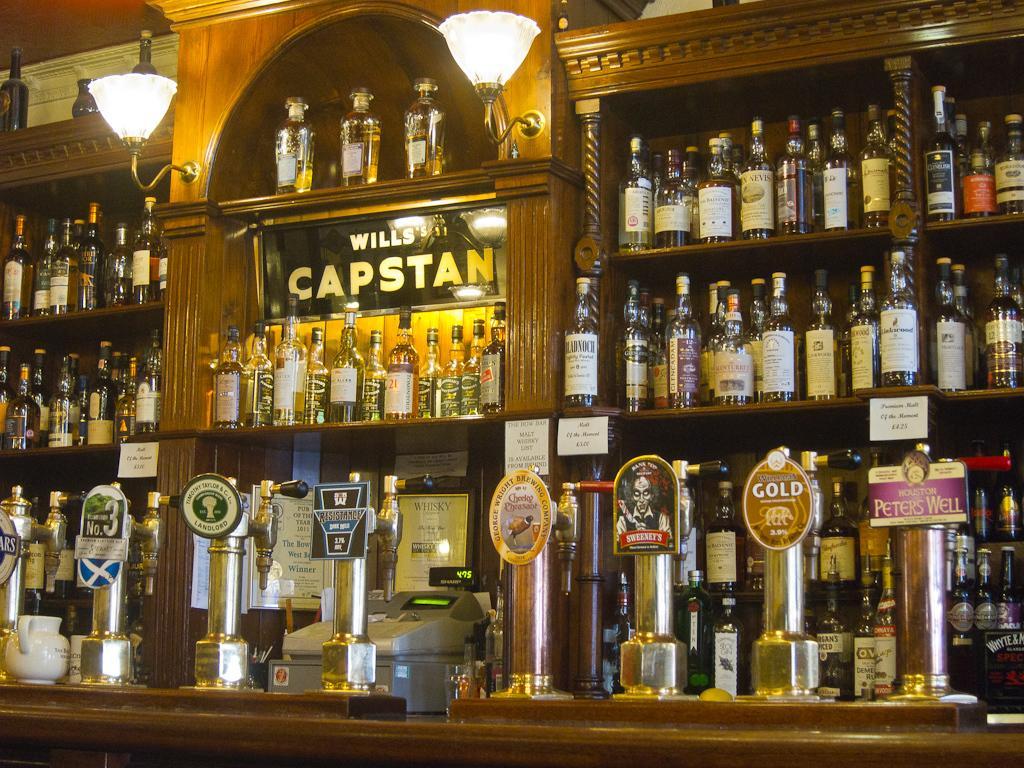Can you describe this image briefly? In this picture there are many bottles which are placed in a shelf,There is a light attached to the cupboard. There is a machine on the table. 